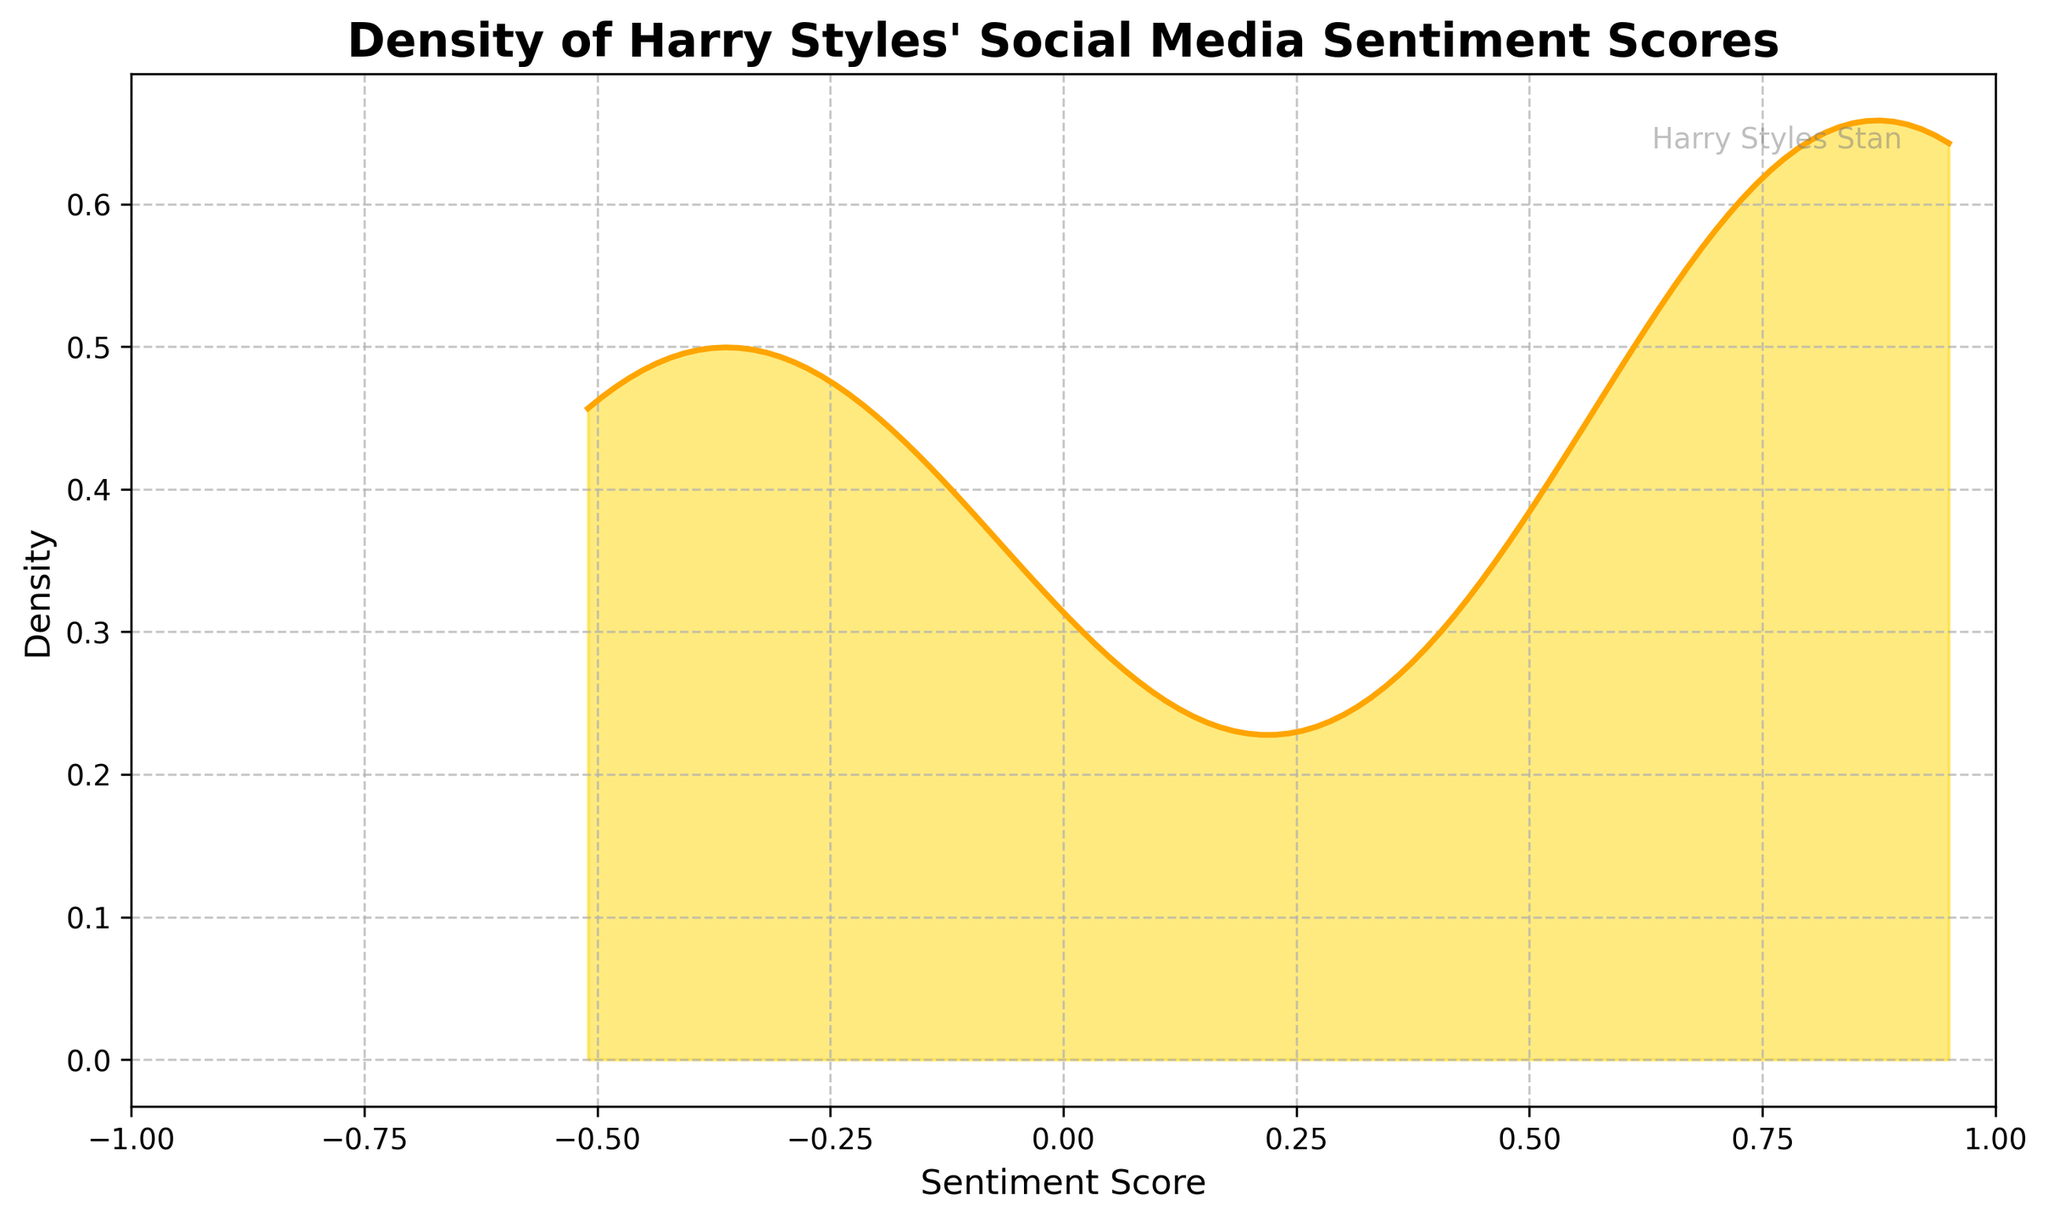What is the title of the plot? The title is typically found at the top of the plot. It is a large, bold text summarizing what the plot illustrates.
Answer: Density of Harry Styles' Social Media Sentiment Scores What does the x-axis represent? The x-axis is labeled at the bottom of the plot and it indicates the variable being measured horizontally.
Answer: Sentiment Score What does the y-axis represent? The y-axis is labeled at the side of the plot and it represents the variable being measured vertically.
Answer: Density What color is used to fill the area under the density curve? The plot area under the density curve is shaded to visually distinguish the area representing density.
Answer: Golden yellow Where is the plot's watermark located? The watermark is typically a light or semi-transparent text or image that marks the plot with an identifier, usually placed subtly so it doesn't distract.
Answer: Top-right corner Which sentiment score range has the highest density? To determine the highest density, observe where the density curve peaks the most on the plot. This range corresponds to the highest value on the curve.
Answer: Around 0.85-0.95 Does the density plot display more negative or more positive sentiment scores? By observing the concentration and shape of the density plot on the negative and positive sides of the sentiment score axis. If most values are clumped towards the positive side, more positive scores are present.
Answer: More positive sentiment scores Are there any sentiment scores beyond -0.5 and 1? Check the plot's x-axis limits for the smallest and largest values to see if there are any scores that go beyond -0.5 and 1.
Answer: No, the scores span within -0.5 and 1 Around which sentiment score does the density start to decrease? Identify the point on the x-axis where the density curve changes from increasing to decreasing.
Answer: Around 0.95 